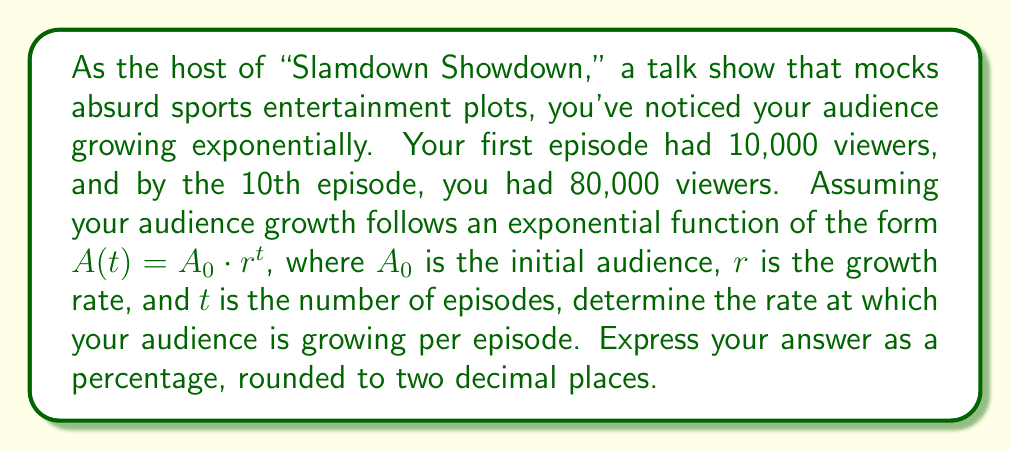Provide a solution to this math problem. Let's approach this step-by-step:

1) We're given that the exponential function has the form $A(t) = A_0 \cdot r^t$

2) We know:
   $A_0 = 10,000$ (initial audience)
   $A(10) = 80,000$ (audience after 10 episodes)

3) Let's plug these values into our equation:
   $80,000 = 10,000 \cdot r^{10}$

4) Divide both sides by 10,000:
   $8 = r^{10}$

5) To solve for $r$, we need to take the 10th root of both sides:
   $r = \sqrt[10]{8}$

6) We can calculate this:
   $r \approx 1.2589$

7) To express this as a percentage increase, we subtract 1 and multiply by 100:
   $(1.2589 - 1) \times 100 \approx 25.89\%$

8) Rounding to two decimal places:
   $25.89\%$
Answer: The audience is growing at a rate of 25.89% per episode. 